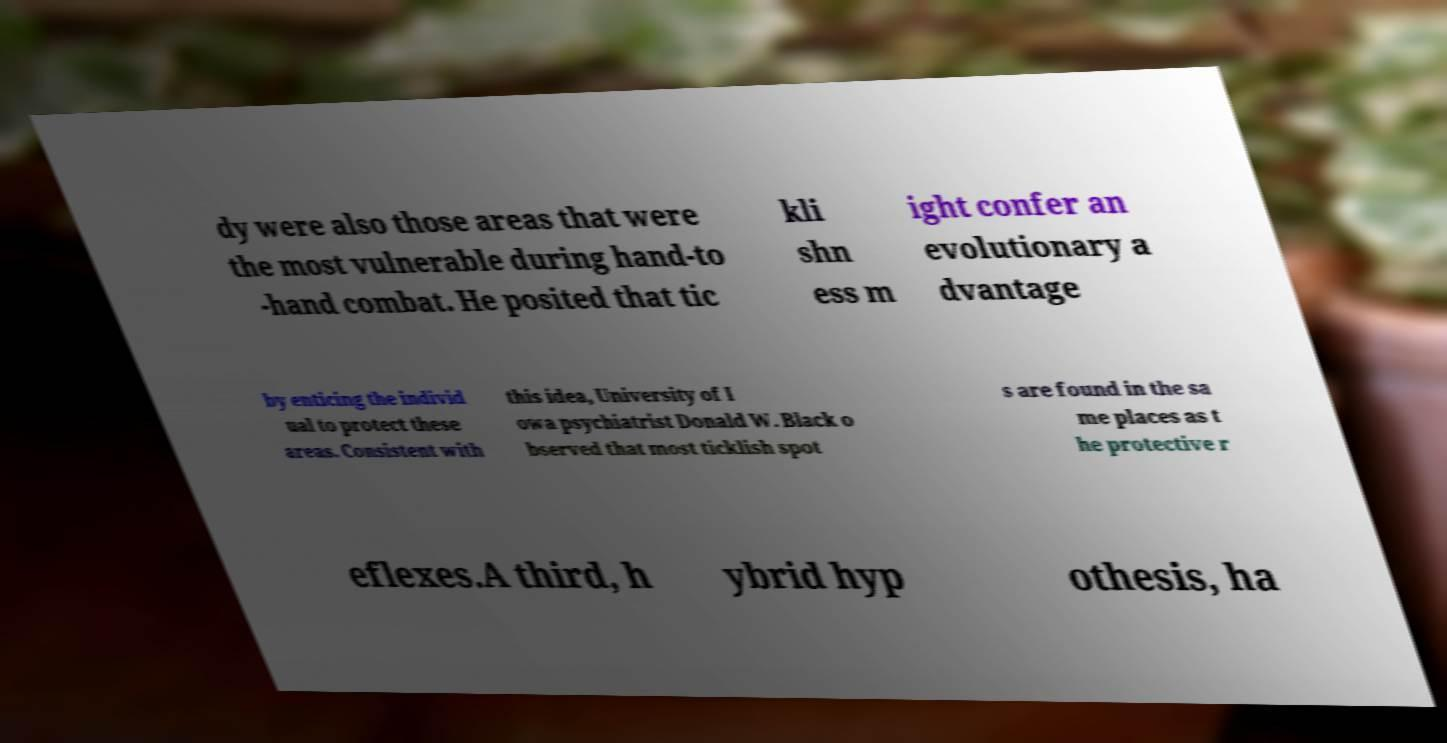What messages or text are displayed in this image? I need them in a readable, typed format. dy were also those areas that were the most vulnerable during hand-to -hand combat. He posited that tic kli shn ess m ight confer an evolutionary a dvantage by enticing the individ ual to protect these areas. Consistent with this idea, University of I owa psychiatrist Donald W. Black o bserved that most ticklish spot s are found in the sa me places as t he protective r eflexes.A third, h ybrid hyp othesis, ha 